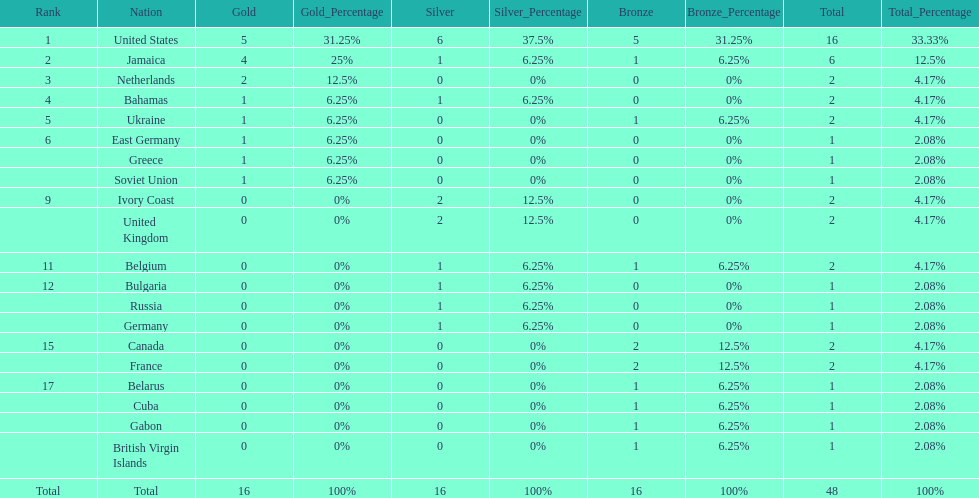How many nations won more than one silver medal? 3. 